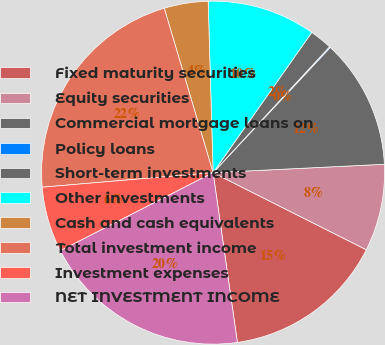Convert chart. <chart><loc_0><loc_0><loc_500><loc_500><pie_chart><fcel>Fixed maturity securities<fcel>Equity securities<fcel>Commercial mortgage loans on<fcel>Policy loans<fcel>Short-term investments<fcel>Other investments<fcel>Cash and cash equivalents<fcel>Total investment income<fcel>Investment expenses<fcel>NET INVESTMENT INCOME<nl><fcel>15.32%<fcel>8.2%<fcel>12.25%<fcel>0.09%<fcel>2.12%<fcel>10.22%<fcel>4.14%<fcel>21.76%<fcel>6.17%<fcel>19.74%<nl></chart> 